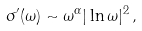<formula> <loc_0><loc_0><loc_500><loc_500>\sigma ^ { \prime } ( \omega ) \sim \omega ^ { \alpha } | \ln \omega | ^ { 2 } \, ,</formula> 